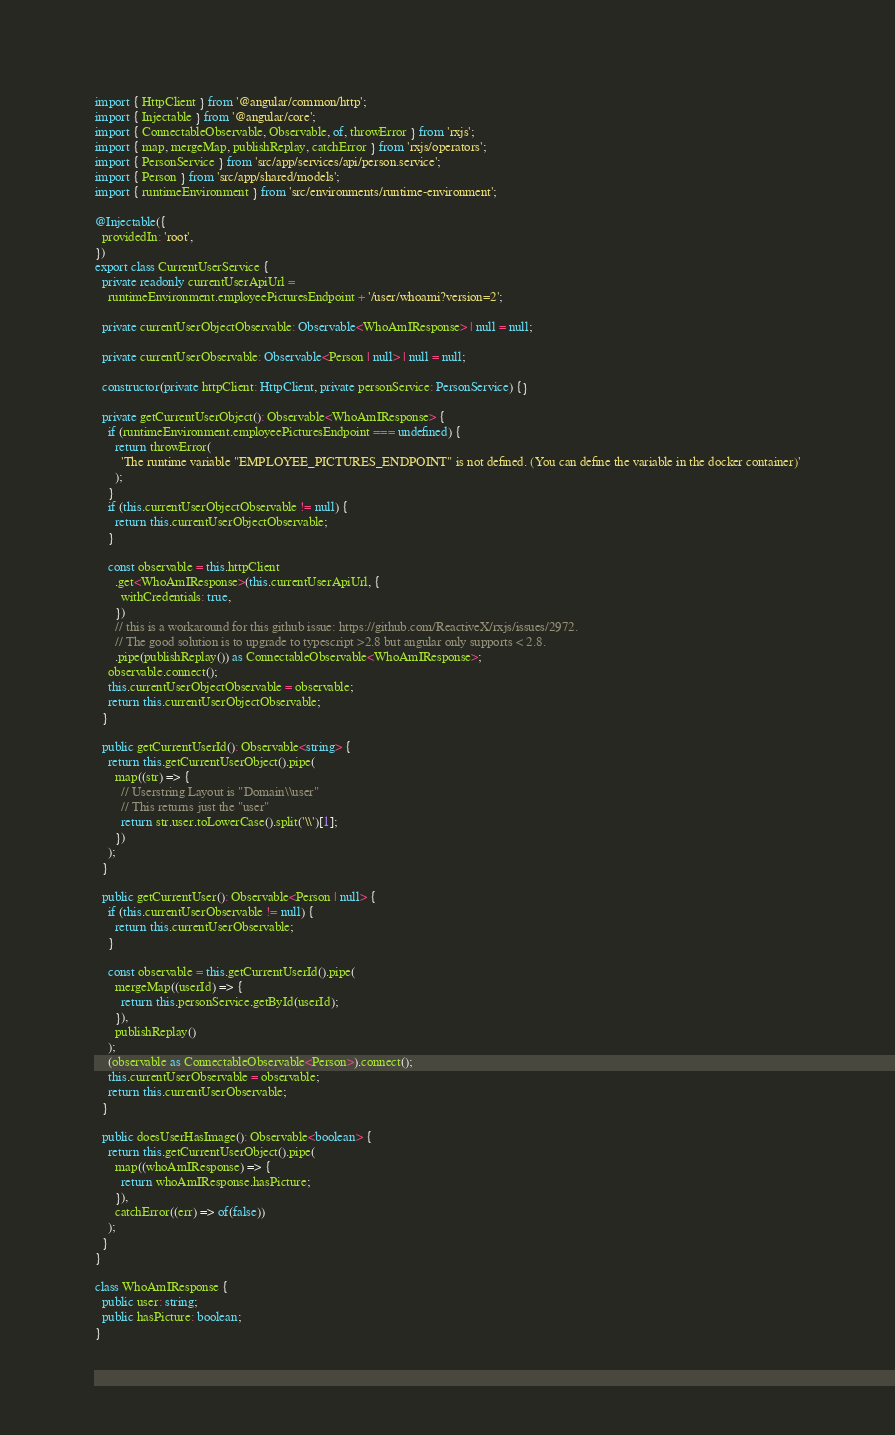<code> <loc_0><loc_0><loc_500><loc_500><_TypeScript_>import { HttpClient } from '@angular/common/http';
import { Injectable } from '@angular/core';
import { ConnectableObservable, Observable, of, throwError } from 'rxjs';
import { map, mergeMap, publishReplay, catchError } from 'rxjs/operators';
import { PersonService } from 'src/app/services/api/person.service';
import { Person } from 'src/app/shared/models';
import { runtimeEnvironment } from 'src/environments/runtime-environment';

@Injectable({
  providedIn: 'root',
})
export class CurrentUserService {
  private readonly currentUserApiUrl =
    runtimeEnvironment.employeePicturesEndpoint + '/user/whoami?version=2';

  private currentUserObjectObservable: Observable<WhoAmIResponse> | null = null;

  private currentUserObservable: Observable<Person | null> | null = null;

  constructor(private httpClient: HttpClient, private personService: PersonService) {}

  private getCurrentUserObject(): Observable<WhoAmIResponse> {
    if (runtimeEnvironment.employeePicturesEndpoint === undefined) {
      return throwError(
        'The runtime variable "EMPLOYEE_PICTURES_ENDPOINT" is not defined. (You can define the variable in the docker container)'
      );
    }
    if (this.currentUserObjectObservable != null) {
      return this.currentUserObjectObservable;
    }

    const observable = this.httpClient
      .get<WhoAmIResponse>(this.currentUserApiUrl, {
        withCredentials: true,
      })
      // this is a workaround for this github issue: https://github.com/ReactiveX/rxjs/issues/2972.
      // The good solution is to upgrade to typescript >2.8 but angular only supports < 2.8.
      .pipe(publishReplay()) as ConnectableObservable<WhoAmIResponse>;
    observable.connect();
    this.currentUserObjectObservable = observable;
    return this.currentUserObjectObservable;
  }

  public getCurrentUserId(): Observable<string> {
    return this.getCurrentUserObject().pipe(
      map((str) => {
        // Userstring Layout is "Domain\\user"
        // This returns just the "user"
        return str.user.toLowerCase().split('\\')[1];
      })
    );
  }

  public getCurrentUser(): Observable<Person | null> {
    if (this.currentUserObservable != null) {
      return this.currentUserObservable;
    }

    const observable = this.getCurrentUserId().pipe(
      mergeMap((userId) => {
        return this.personService.getById(userId);
      }),
      publishReplay()
    );
    (observable as ConnectableObservable<Person>).connect();
    this.currentUserObservable = observable;
    return this.currentUserObservable;
  }

  public doesUserHasImage(): Observable<boolean> {
    return this.getCurrentUserObject().pipe(
      map((whoAmIResponse) => {
        return whoAmIResponse.hasPicture;
      }),
      catchError((err) => of(false))
    );
  }
}

class WhoAmIResponse {
  public user: string;
  public hasPicture: boolean;
}
</code> 